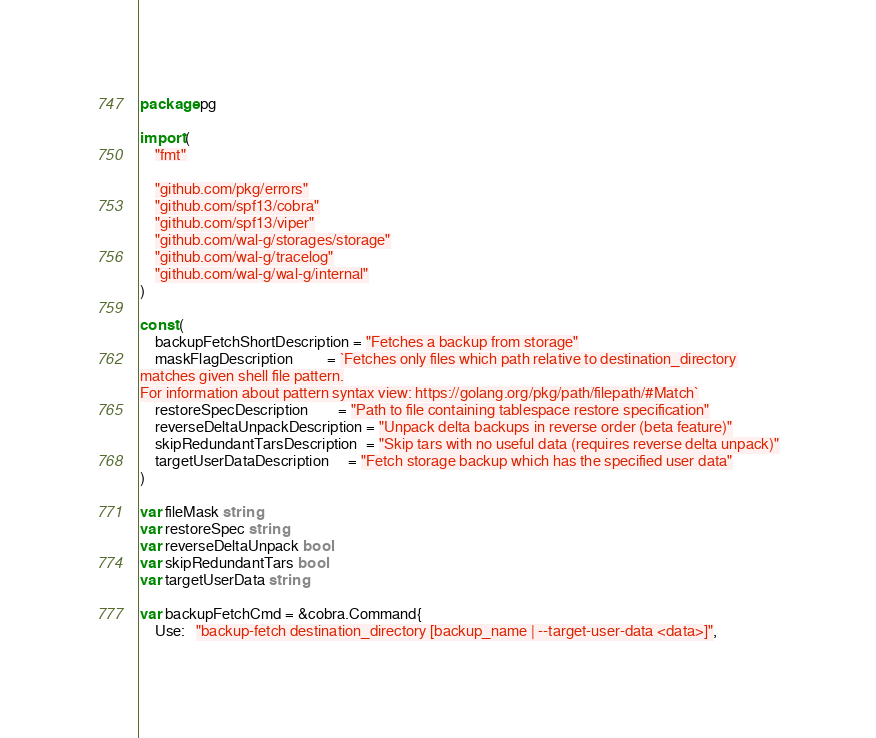Convert code to text. <code><loc_0><loc_0><loc_500><loc_500><_Go_>package pg

import (
	"fmt"

	"github.com/pkg/errors"
	"github.com/spf13/cobra"
	"github.com/spf13/viper"
	"github.com/wal-g/storages/storage"
	"github.com/wal-g/tracelog"
	"github.com/wal-g/wal-g/internal"
)

const (
	backupFetchShortDescription = "Fetches a backup from storage"
	maskFlagDescription         = `Fetches only files which path relative to destination_directory
matches given shell file pattern.
For information about pattern syntax view: https://golang.org/pkg/path/filepath/#Match`
	restoreSpecDescription        = "Path to file containing tablespace restore specification"
	reverseDeltaUnpackDescription = "Unpack delta backups in reverse order (beta feature)"
	skipRedundantTarsDescription  = "Skip tars with no useful data (requires reverse delta unpack)"
	targetUserDataDescription     = "Fetch storage backup which has the specified user data"
)

var fileMask string
var restoreSpec string
var reverseDeltaUnpack bool
var skipRedundantTars bool
var targetUserData string

var backupFetchCmd = &cobra.Command{
	Use:   "backup-fetch destination_directory [backup_name | --target-user-data <data>]",</code> 